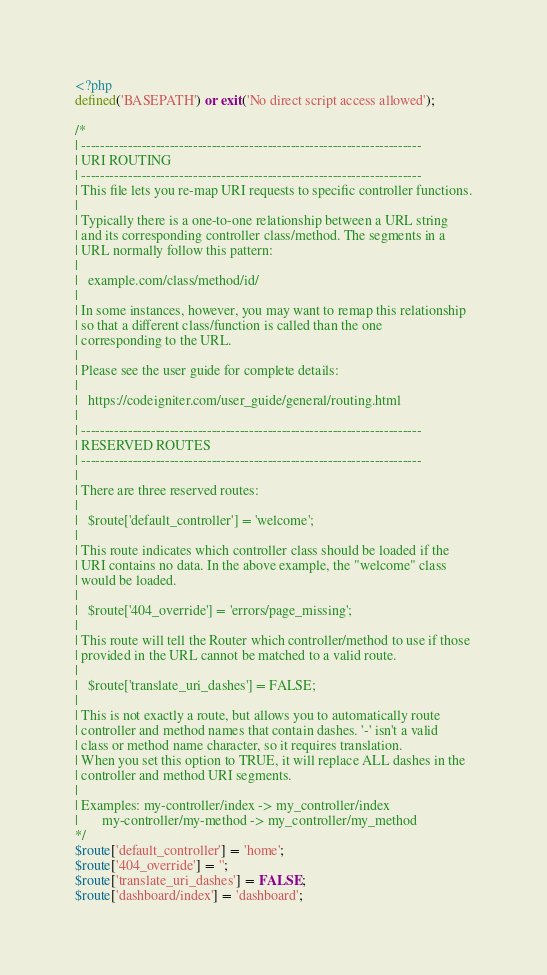<code> <loc_0><loc_0><loc_500><loc_500><_PHP_><?php
defined('BASEPATH') or exit('No direct script access allowed');

/*
| -------------------------------------------------------------------------
| URI ROUTING
| -------------------------------------------------------------------------
| This file lets you re-map URI requests to specific controller functions.
|
| Typically there is a one-to-one relationship between a URL string
| and its corresponding controller class/method. The segments in a
| URL normally follow this pattern:
|
|	example.com/class/method/id/
|
| In some instances, however, you may want to remap this relationship
| so that a different class/function is called than the one
| corresponding to the URL.
|
| Please see the user guide for complete details:
|
|	https://codeigniter.com/user_guide/general/routing.html
|
| -------------------------------------------------------------------------
| RESERVED ROUTES
| -------------------------------------------------------------------------
|
| There are three reserved routes:
|
|	$route['default_controller'] = 'welcome';
|
| This route indicates which controller class should be loaded if the
| URI contains no data. In the above example, the "welcome" class
| would be loaded.
|
|	$route['404_override'] = 'errors/page_missing';
|
| This route will tell the Router which controller/method to use if those
| provided in the URL cannot be matched to a valid route.
|
|	$route['translate_uri_dashes'] = FALSE;
|
| This is not exactly a route, but allows you to automatically route
| controller and method names that contain dashes. '-' isn't a valid
| class or method name character, so it requires translation.
| When you set this option to TRUE, it will replace ALL dashes in the
| controller and method URI segments.
|
| Examples:	my-controller/index	-> my_controller/index
|		my-controller/my-method	-> my_controller/my_method
*/
$route['default_controller'] = 'home';
$route['404_override'] = '';
$route['translate_uri_dashes'] = FALSE;
$route['dashboard/index'] = 'dashboard';
</code> 